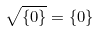Convert formula to latex. <formula><loc_0><loc_0><loc_500><loc_500>\sqrt { \{ 0 \} } = \{ 0 \}</formula> 